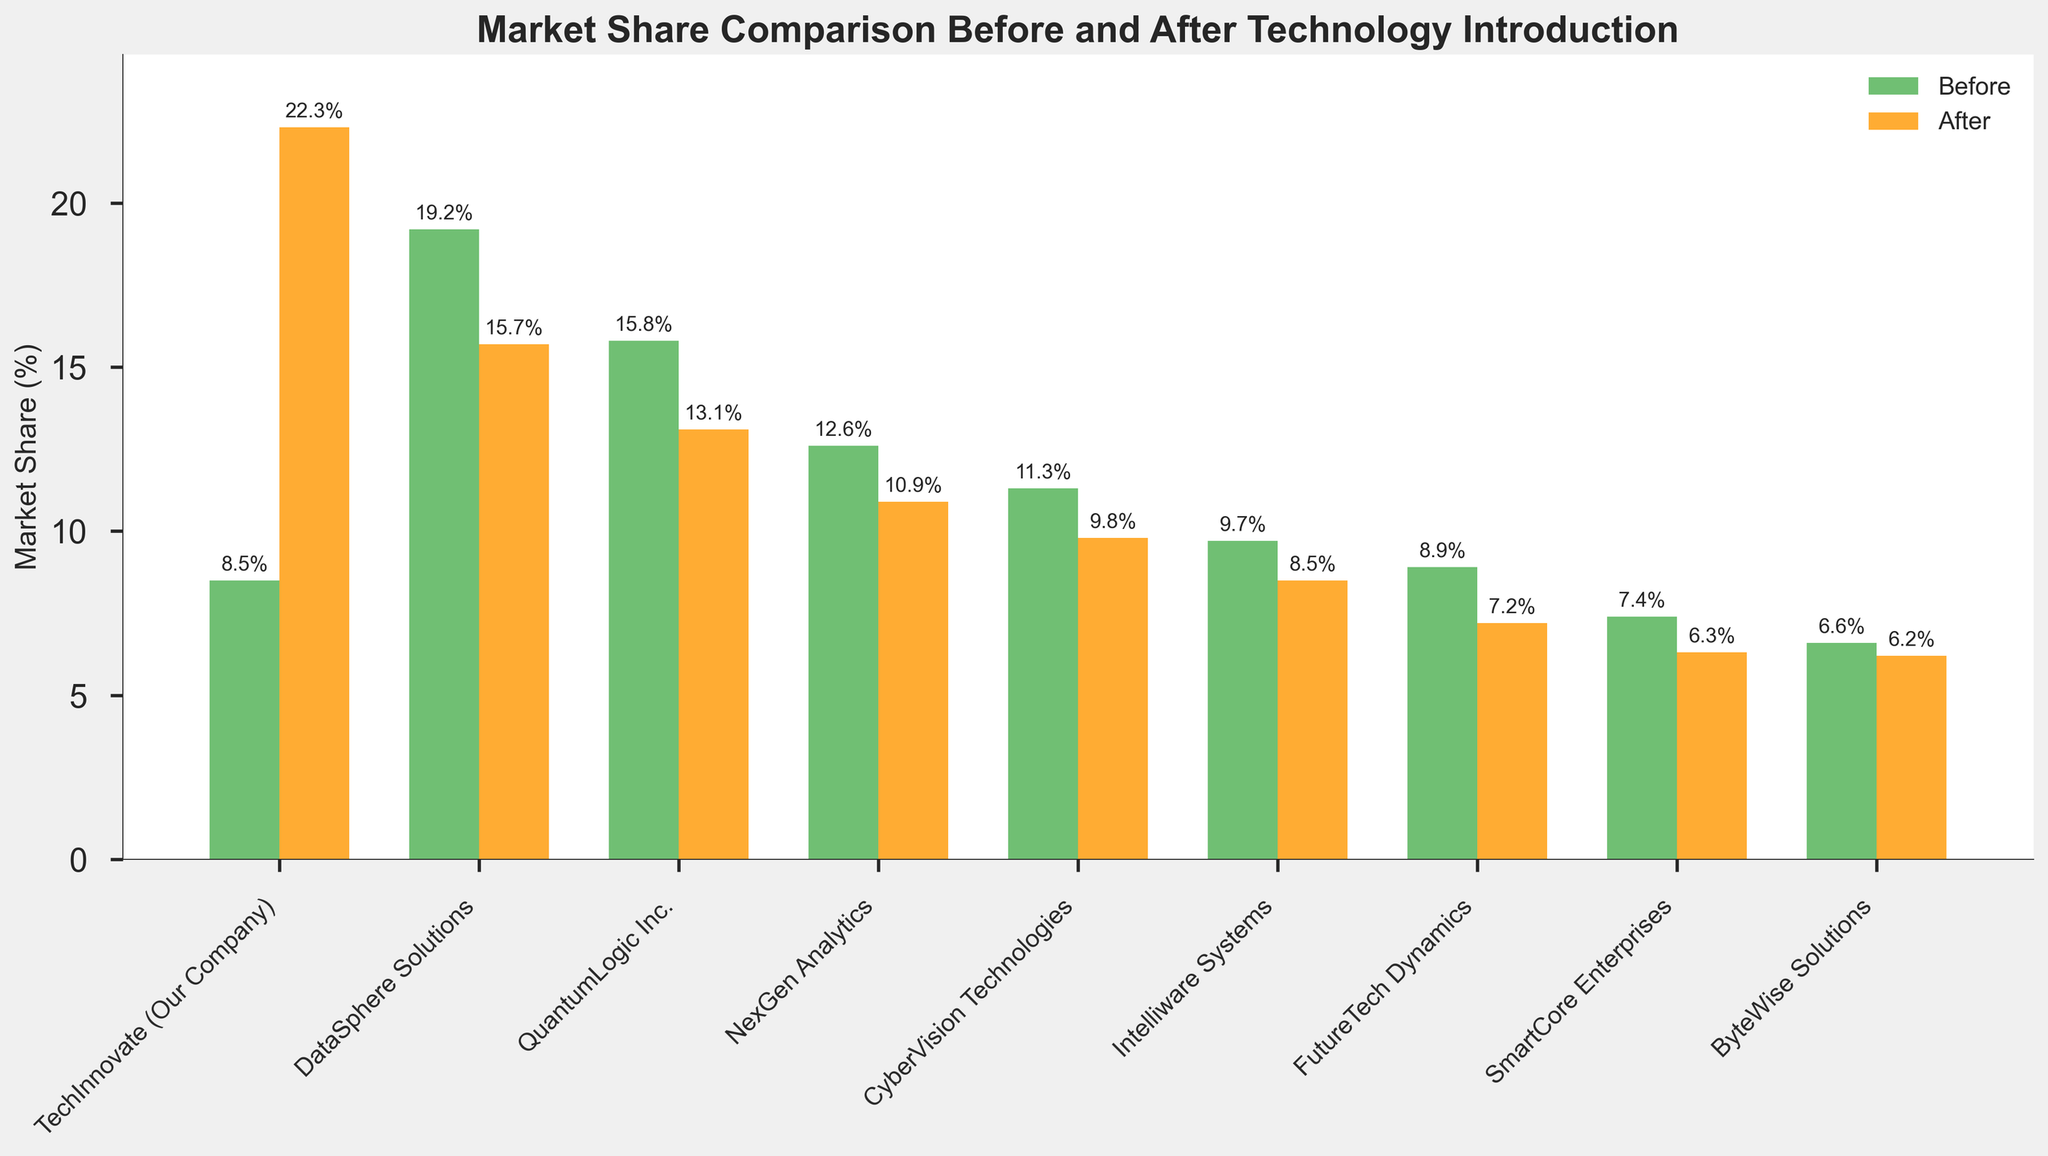Which company had the highest increase in market share after the technology's introduction? First, identify the market share before and after the technology's introduction for all companies. Then, calculate the difference for each company and determine which company has the largest positive change. TechInnovate had an increase from 8.5% to 22.3%, which is the highest.
Answer: TechInnovate Which company experienced the largest decrease in market share after the technology's introduction? Identify the market share before and after the technology's introduction for all companies. Then, calculate the difference for each company and determine which company has the largest negative change. FutureTech Dynamics had a decrease from 8.9% to 7.2%, which is the largest drop.
Answer: FutureTech Dynamics How much did TechInnovate's market share increase, in terms of percentage points? Calculate the difference between the market share before and after the introduction for TechInnovate. The values are 8.5% before and 22.3% after. The difference is 22.3% - 8.5% = 13.8 percentage points.
Answer: 13.8 percentage points What is the average market share before the technology's introduction across all companies? Sum the market shares before the introduction for all companies and divide by the number of companies. (8.5 + 19.2 + 15.8 + 12.6 + 11.3 + 9.7 + 8.9 + 7.4 + 6.6)/9 = 11.00%.
Answer: 11.00% Which company had the smallest decrease in market share after the technology's introduction? Calculate the difference between the market share before and after for each company and determine which company has the smallest negative change. ByteWise Solutions had a decrease from 6.6% to 6.2%, the smallest decrease.
Answer: ByteWise Solutions Compare the market share changes between Intelliware Systems and CyberVision Technologies. Which one had a greater decrease? Calculate the differences in market share before and after the technology introduction for both Intelliware Systems and CyberVision Technologies. Intelliware Systems changed from 9.7% to 8.5% (a decrease of 1.2 points) and CyberVision Technologies changed from 11.3% to 9.8% (a decrease of 1.5 points). CyberVision Technologies had a greater decrease.
Answer: CyberVision Technologies What was the total market share for NexGen Analytics and QuantumLogic Inc. before the technology's introduction? Sum the market shares before the technology's introduction for both NexGen Analytics and QuantumLogic Inc. 12.6% (NexGen Analytics) + 15.8% (QuantumLogic Inc.) = 28.4%.
Answer: 28.4% Which companies have a higher market share after the technology's introduction than before? Compare the market share before and after the technology introduction for each company. Determine which companies have a higher value after the introduction. Only TechInnovate increased from 8.5% to 22.3%.
Answer: TechInnovate By how many percentage points did DataSphere Solutions' market share decrease after the introduction of the technology? Calculate the difference between the market share before and after the technology introduction for DataSphere Solutions. The values are 19.2% before and 15.7% after. The difference is 19.2% - 15.7% = 3.5 percentage points.
Answer: 3.5 percentage points 